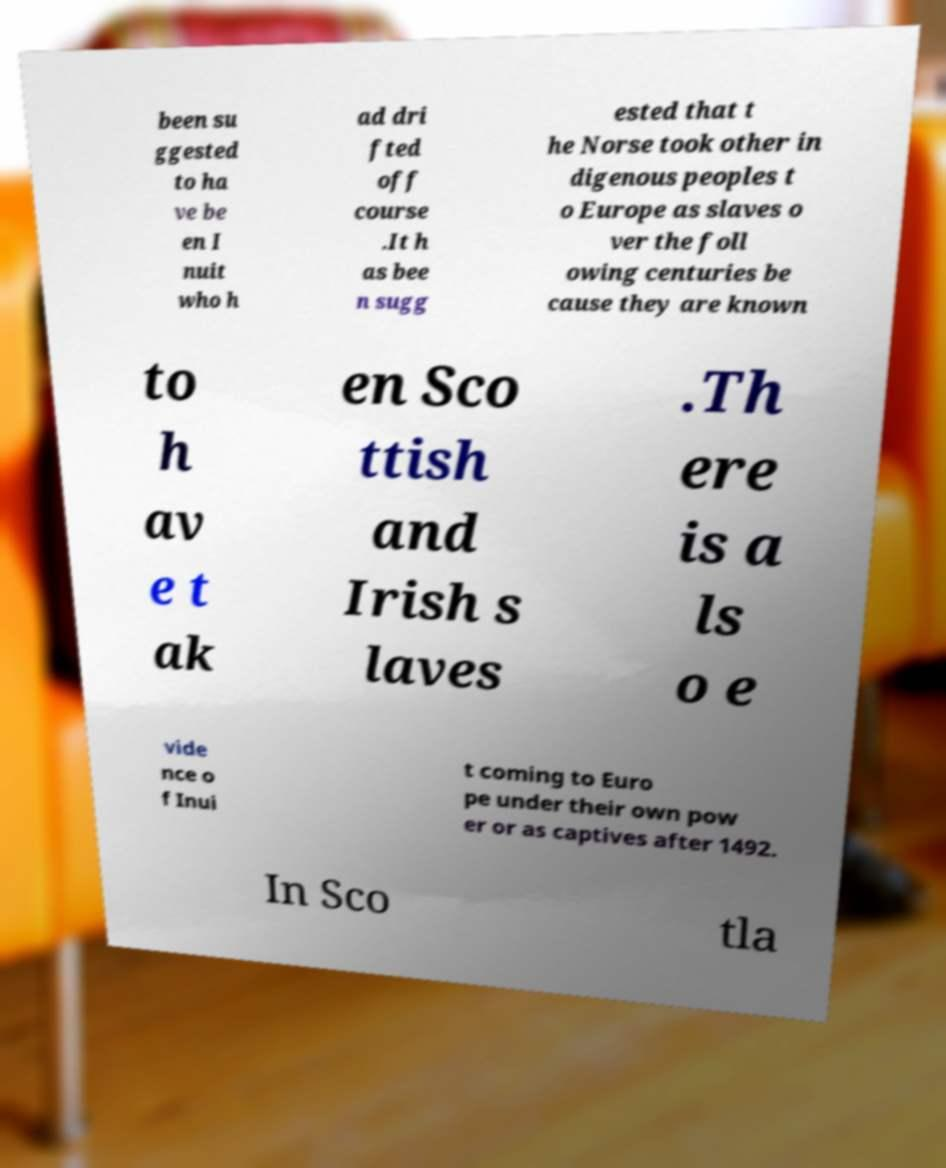Can you accurately transcribe the text from the provided image for me? been su ggested to ha ve be en I nuit who h ad dri fted off course .It h as bee n sugg ested that t he Norse took other in digenous peoples t o Europe as slaves o ver the foll owing centuries be cause they are known to h av e t ak en Sco ttish and Irish s laves .Th ere is a ls o e vide nce o f Inui t coming to Euro pe under their own pow er or as captives after 1492. In Sco tla 